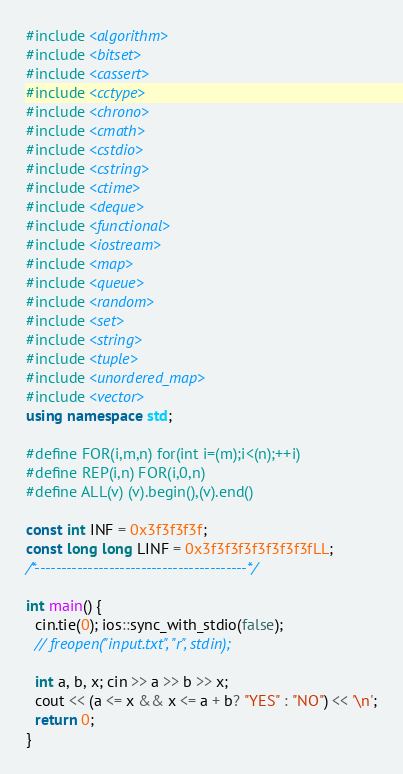<code> <loc_0><loc_0><loc_500><loc_500><_C++_>#include <algorithm>
#include <bitset>
#include <cassert>
#include <cctype>
#include <chrono>
#include <cmath>
#include <cstdio>
#include <cstring>
#include <ctime>
#include <deque>
#include <functional>
#include <iostream>
#include <map>
#include <queue>
#include <random>
#include <set>
#include <string>
#include <tuple>
#include <unordered_map>
#include <vector>
using namespace std;

#define FOR(i,m,n) for(int i=(m);i<(n);++i)
#define REP(i,n) FOR(i,0,n)
#define ALL(v) (v).begin(),(v).end()

const int INF = 0x3f3f3f3f;
const long long LINF = 0x3f3f3f3f3f3f3f3fLL;
/*----------------------------------------*/

int main() {
  cin.tie(0); ios::sync_with_stdio(false);
  // freopen("input.txt", "r", stdin);

  int a, b, x; cin >> a >> b >> x;
  cout << (a <= x && x <= a + b? "YES" : "NO") << '\n';
  return 0;
}
</code> 